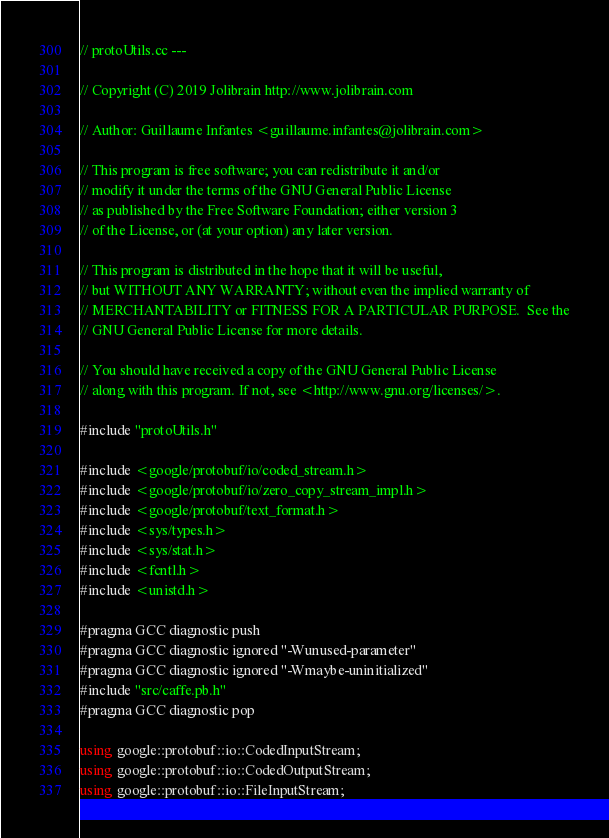Convert code to text. <code><loc_0><loc_0><loc_500><loc_500><_C++_>
// protoUtils.cc ---

// Copyright (C) 2019 Jolibrain http://www.jolibrain.com

// Author: Guillaume Infantes <guillaume.infantes@jolibrain.com>

// This program is free software; you can redistribute it and/or
// modify it under the terms of the GNU General Public License
// as published by the Free Software Foundation; either version 3
// of the License, or (at your option) any later version.

// This program is distributed in the hope that it will be useful,
// but WITHOUT ANY WARRANTY; without even the implied warranty of
// MERCHANTABILITY or FITNESS FOR A PARTICULAR PURPOSE.  See the
// GNU General Public License for more details.

// You should have received a copy of the GNU General Public License
// along with this program. If not, see <http://www.gnu.org/licenses/>.

#include "protoUtils.h"

#include <google/protobuf/io/coded_stream.h>
#include <google/protobuf/io/zero_copy_stream_impl.h>
#include <google/protobuf/text_format.h>
#include <sys/types.h>
#include <sys/stat.h>
#include <fcntl.h>
#include <unistd.h>

#pragma GCC diagnostic push
#pragma GCC diagnostic ignored "-Wunused-parameter"
#pragma GCC diagnostic ignored "-Wmaybe-uninitialized"
#include "src/caffe.pb.h"
#pragma GCC diagnostic pop

using google::protobuf::io::CodedInputStream;
using google::protobuf::io::CodedOutputStream;
using google::protobuf::io::FileInputStream;</code> 